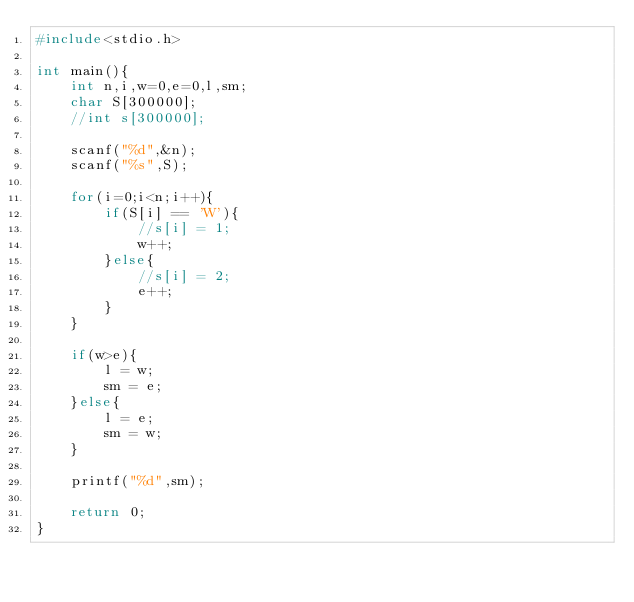<code> <loc_0><loc_0><loc_500><loc_500><_C++_>#include<stdio.h>

int main(){
    int n,i,w=0,e=0,l,sm;
    char S[300000];
    //int s[300000];

    scanf("%d",&n);
    scanf("%s",S);

    for(i=0;i<n;i++){
        if(S[i] == 'W'){
            //s[i] = 1;
            w++;
        }else{
            //s[i] = 2;
            e++;
        }
    }

    if(w>e){
        l = w;
        sm = e;
    }else{
        l = e;
        sm = w;
    }

    printf("%d",sm);

    return 0;
}
</code> 